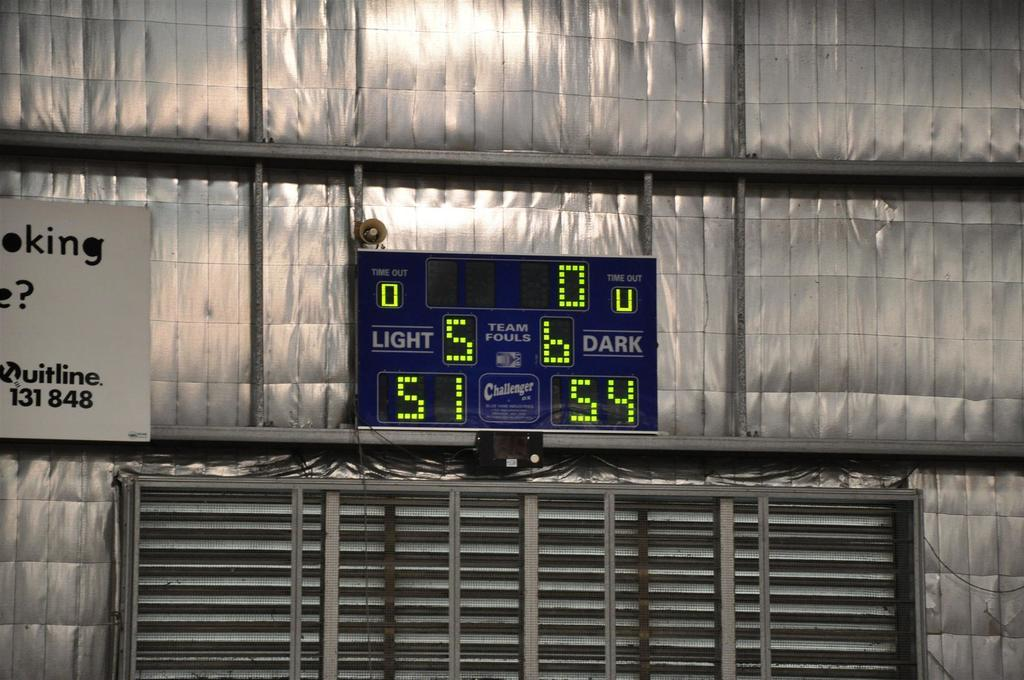<image>
Render a clear and concise summary of the photo. A large sign with LED letters shows the score of a game and keeps track of Team Fouls. 